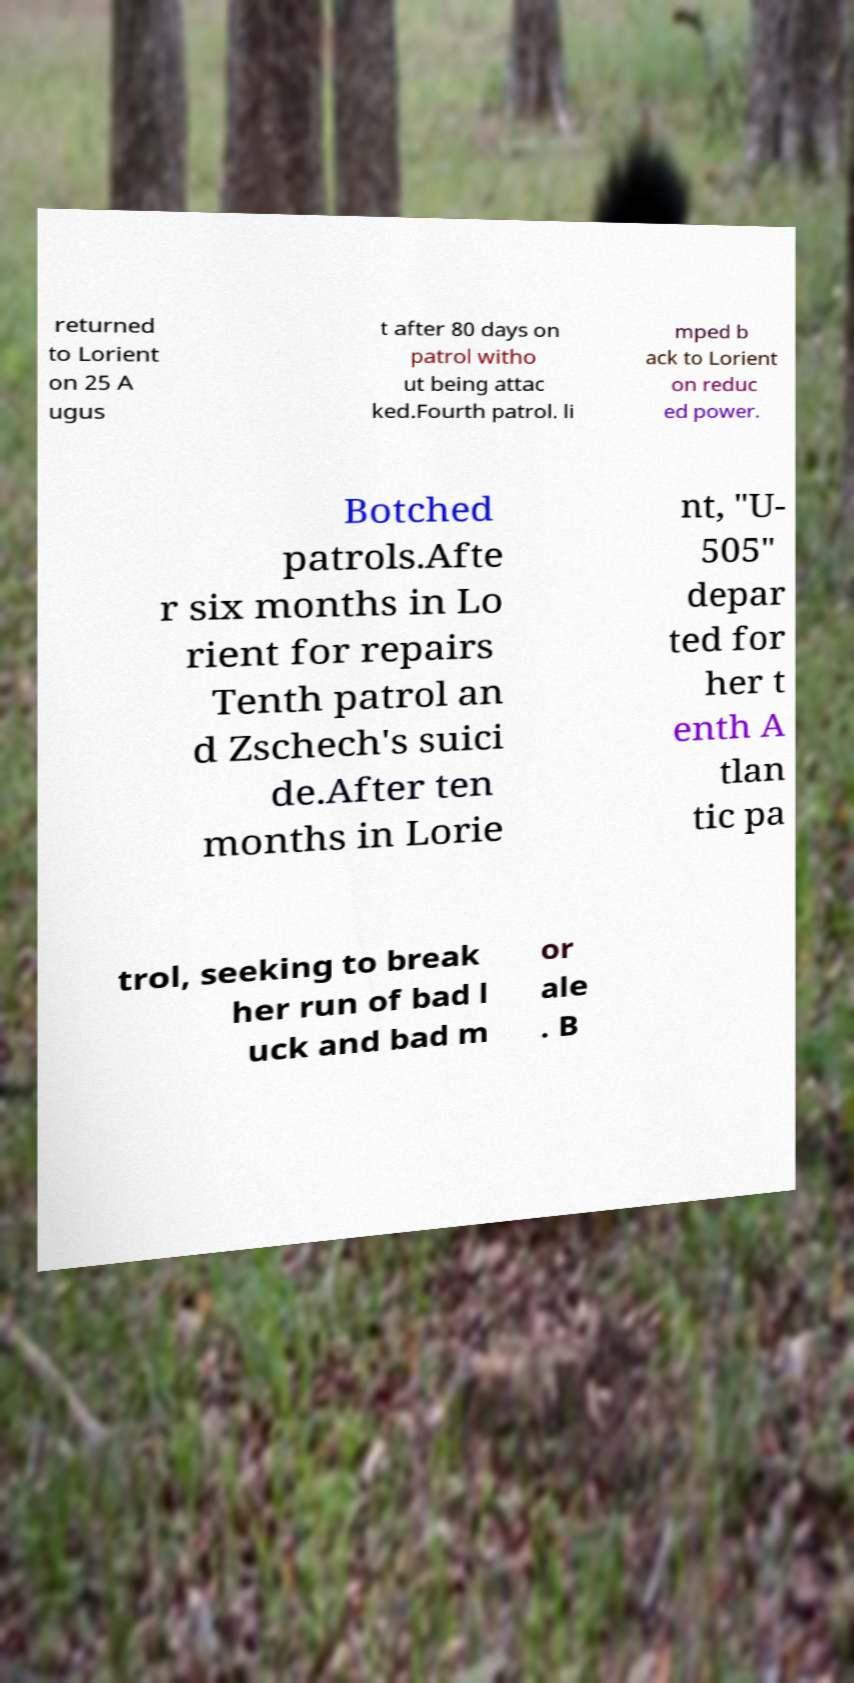Could you assist in decoding the text presented in this image and type it out clearly? returned to Lorient on 25 A ugus t after 80 days on patrol witho ut being attac ked.Fourth patrol. li mped b ack to Lorient on reduc ed power. Botched patrols.Afte r six months in Lo rient for repairs Tenth patrol an d Zschech's suici de.After ten months in Lorie nt, "U- 505" depar ted for her t enth A tlan tic pa trol, seeking to break her run of bad l uck and bad m or ale . B 